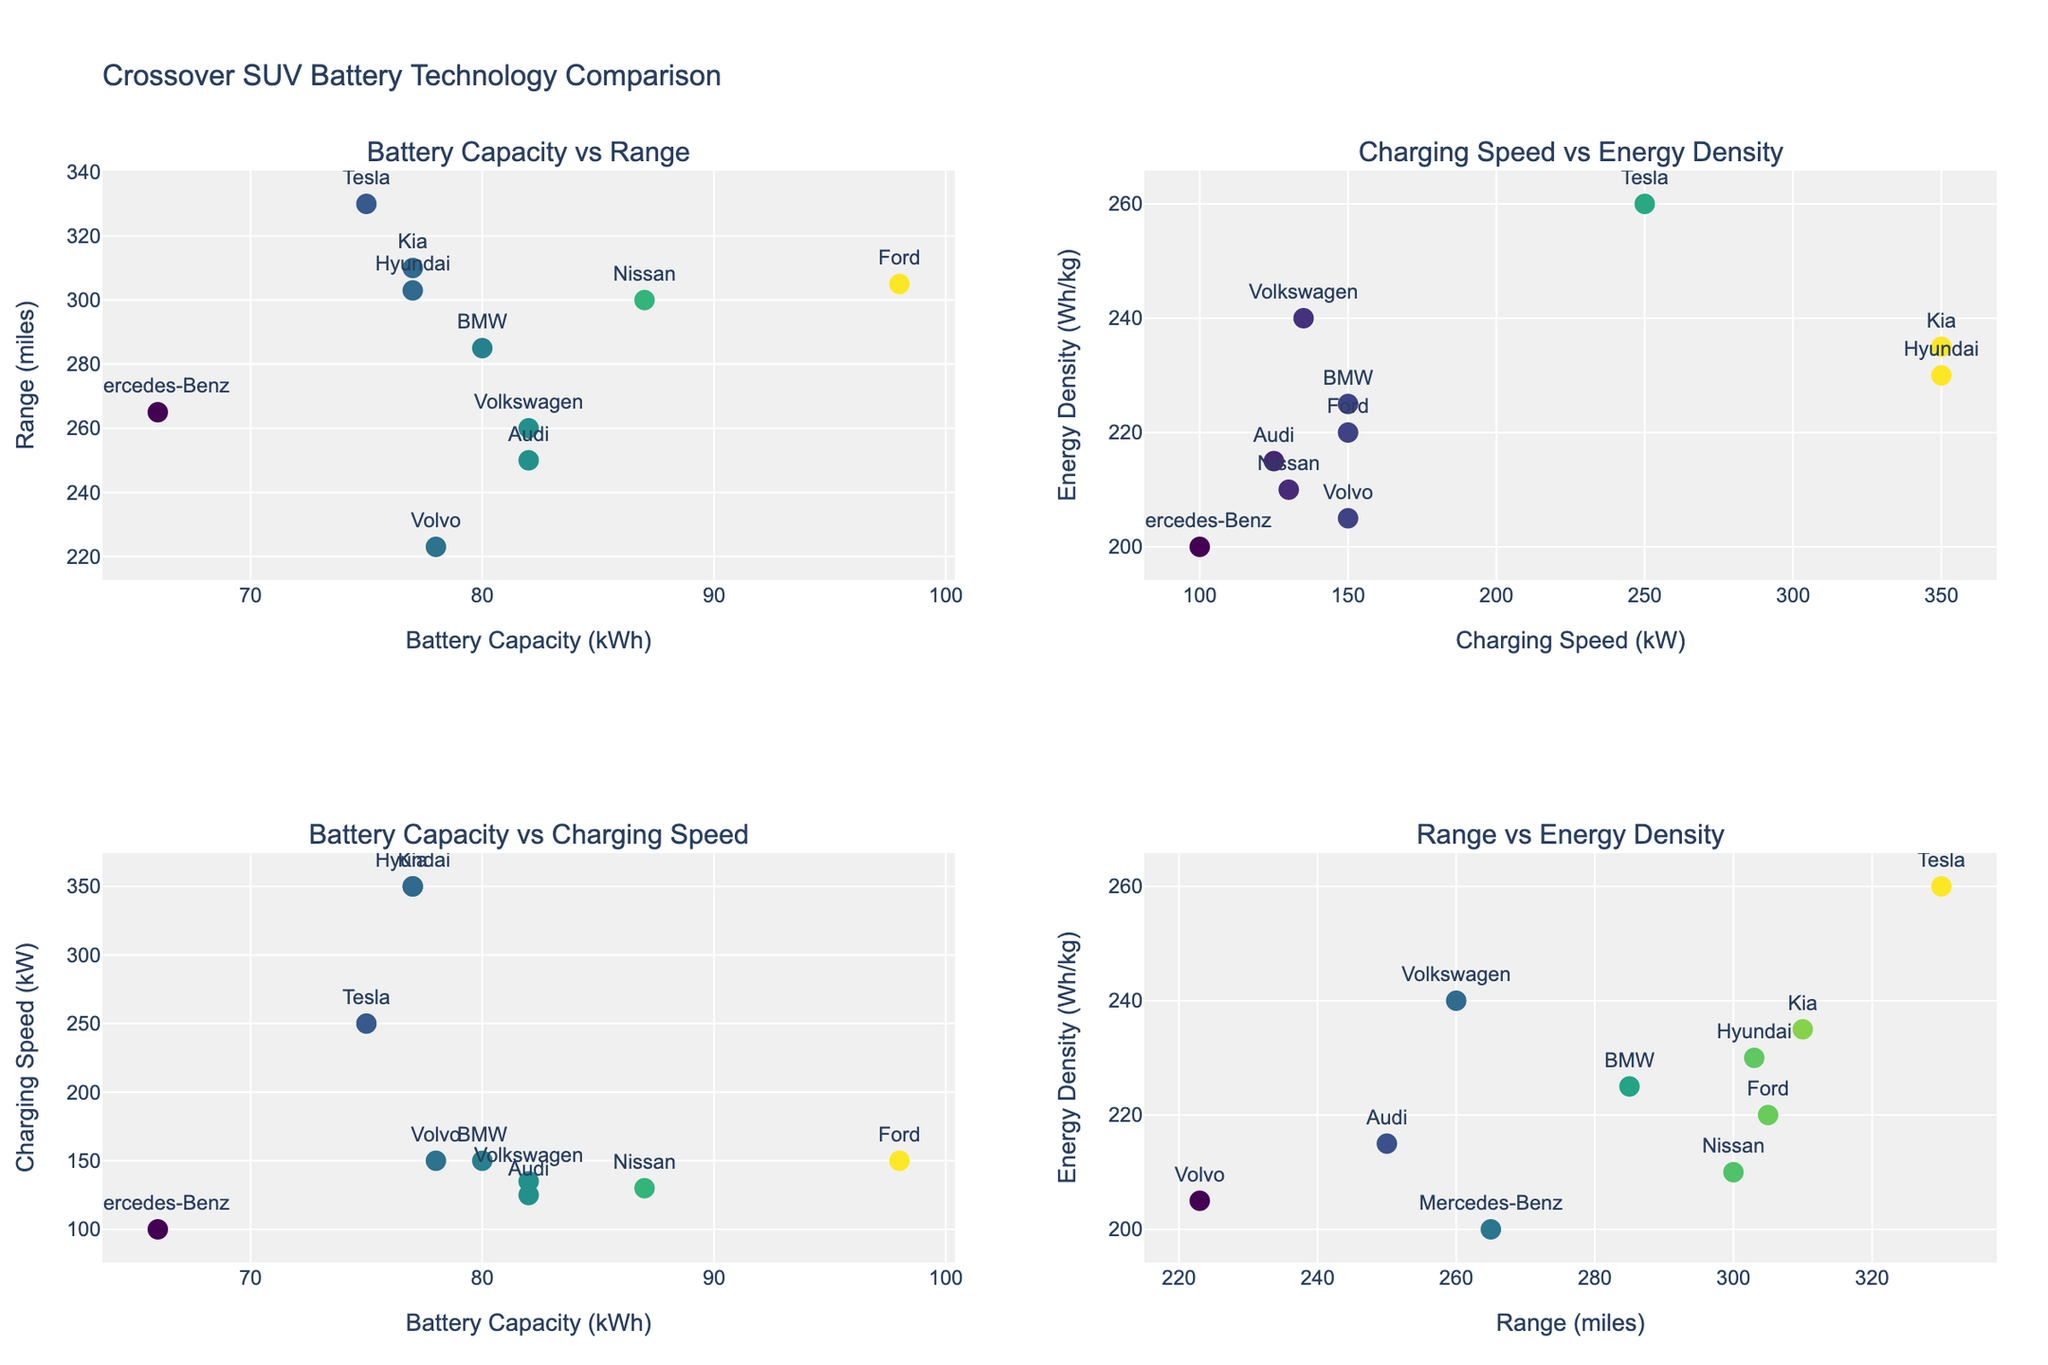What's the relationship between battery capacity and range for Tesla Model Y? Look at the top-left subplot titled "Battery Capacity vs Range." Tesla Model Y is a point on this plot. From the x-axis and y-axis, we see that Tesla Model Y has a battery capacity of 75 kWh and a range of 330 miles.
Answer: 75 kWh and 330 miles Which manufacturer has the highest charging speed, and what is its value? Refer to the top-right subplot titled "Charging Speed vs Energy Density." The point at the highest position on the x-axis represents the highest charging speed. From the annotations, Hyundai and Kia have the highest charging speed of 350 kW.
Answer: Hyundai and Kia, 350 kW Does higher energy density correlate with a longer range? Compare the bottom-right subplot titled "Range vs Energy Density." Examine if points with higher y-values (energy density) correspond to higher x-values (range). There’s no clear trend that higher energy density directly leads to a longer range as points are scattered.
Answer: No clear correlation Which model has the lowest energy density, and what is its corresponding range? Look at the bottom-right subplot titled "Range vs Energy Density." Identify the point with the lowest y-value (energy density). Mercedes-Benz EQA has the lowest energy density of 200 Wh/kg and a range of 265 miles.
Answer: Mercedes-Benz EQA, 265 miles Compare the charging speed of the Ford Mustang Mach-E and Volvo XC40 Recharge. Which has a faster charging speed? Refer to the top-right subplot titled "Charging Speed vs Energy Density" and locate Ford and Volvo data points. Ford Mustang Mach-E has a charging speed of 150 kW, and Volvo XC40 Recharge also has a charging speed of 150 kW. Both have the same charging speed.
Answer: Both have the same speed, 150 kW 